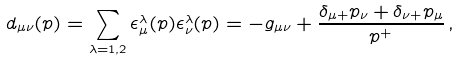<formula> <loc_0><loc_0><loc_500><loc_500>d _ { \mu \nu } ( p ) = \sum _ { \lambda = 1 , 2 } \epsilon _ { \mu } ^ { \lambda } ( p ) \epsilon _ { \nu } ^ { \lambda } ( p ) = - g _ { \mu \nu } + { \frac { \delta _ { \mu + } p _ { \nu } + \delta _ { \nu + } p _ { \mu } } { p ^ { + } } } \, ,</formula> 